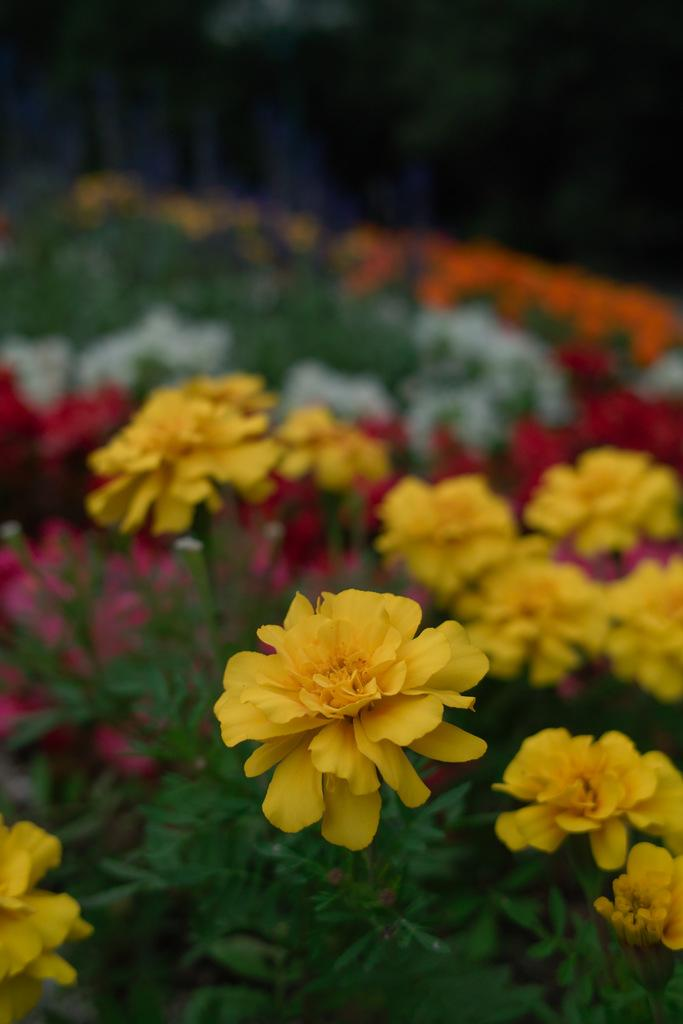What types of living organisms can be seen in the image? Plants and flowers are visible in the image. Can you describe the specific features of the plants in the image? Unfortunately, the top of the image is blurred, so it is difficult to provide specific details about the plants. What type of statement is written as a caption for the image? There is no statement or caption present in the image. How many pizzas are visible in the image? There are no pizzas present in the image. 